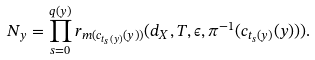Convert formula to latex. <formula><loc_0><loc_0><loc_500><loc_500>N _ { y } = \prod _ { s = 0 } ^ { q ( y ) } r _ { m ( c _ { t _ { s } ( y ) } ( y ) ) } ( d _ { X } , T , \epsilon , \pi ^ { - 1 } ( c _ { t _ { s } ( y ) } ( y ) ) ) .</formula> 